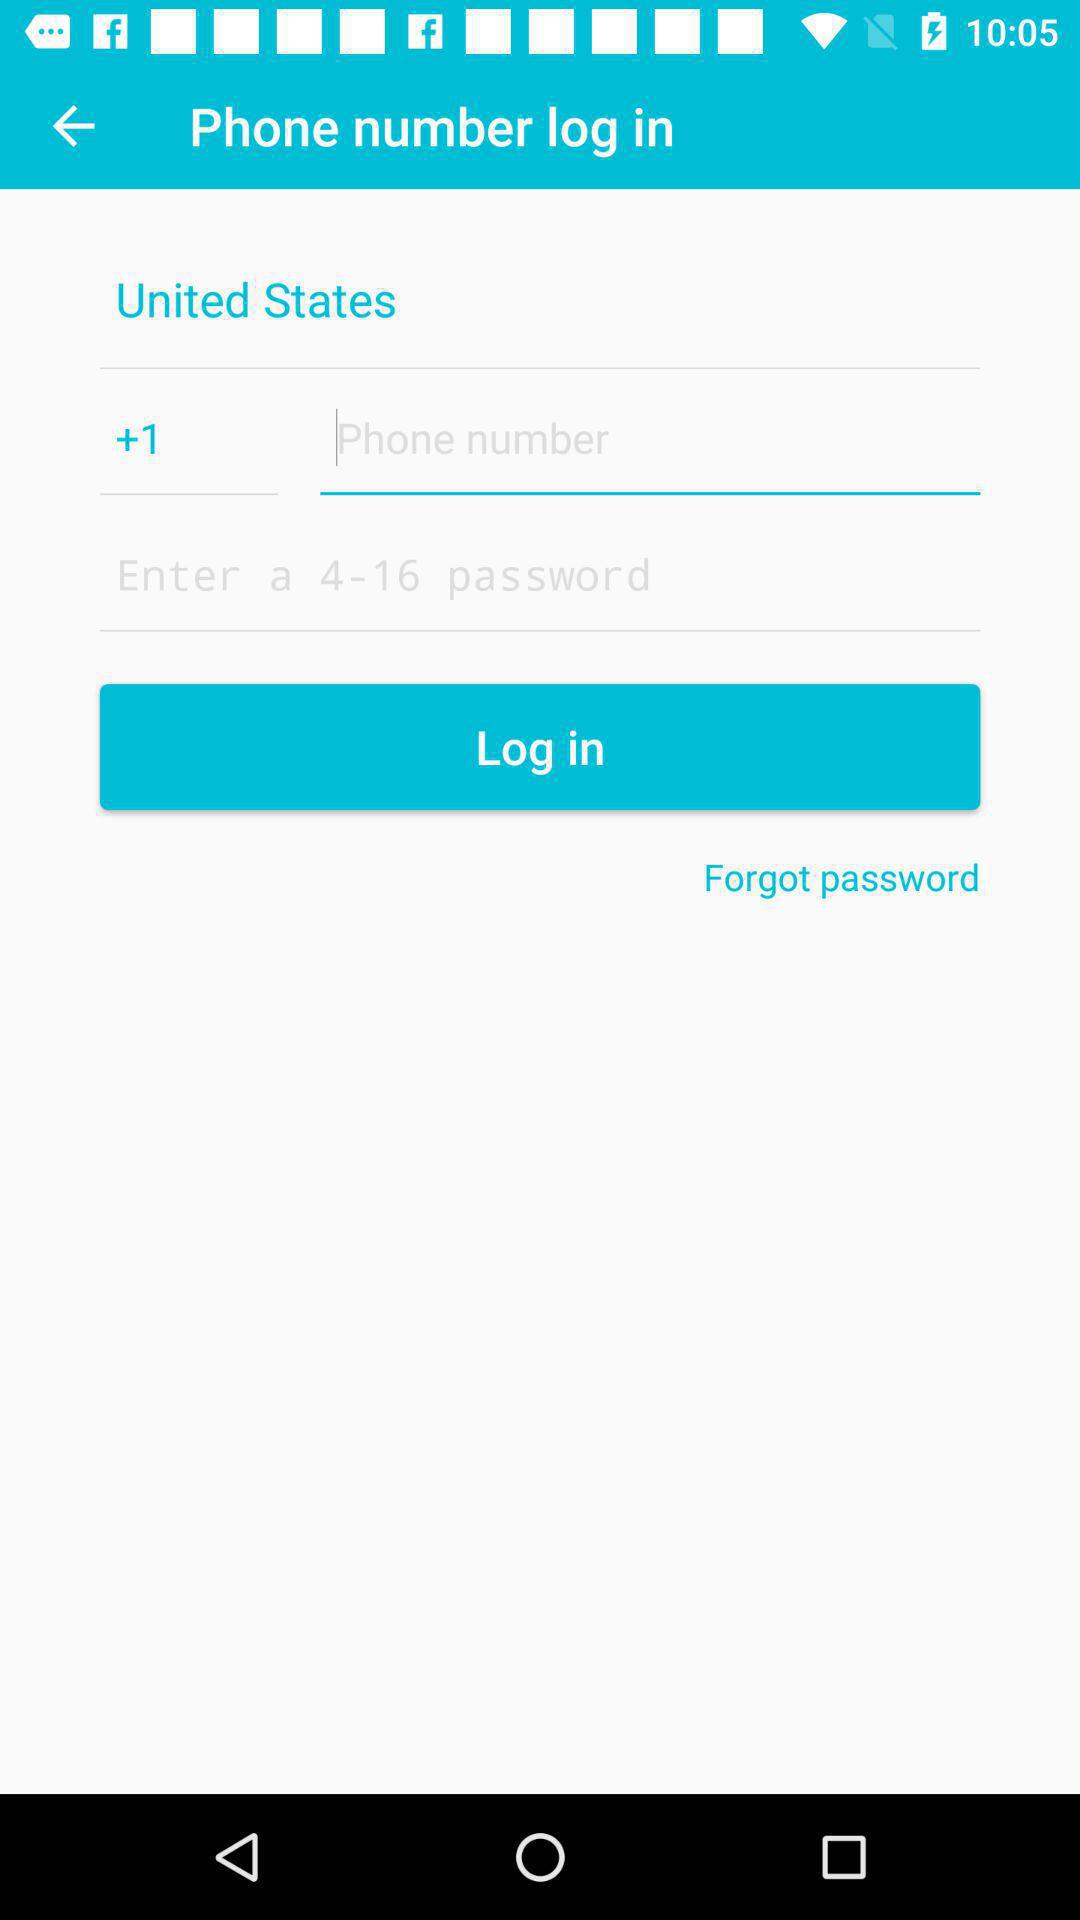What is the maximum word limit for the password? The maximum word limit is 16. 